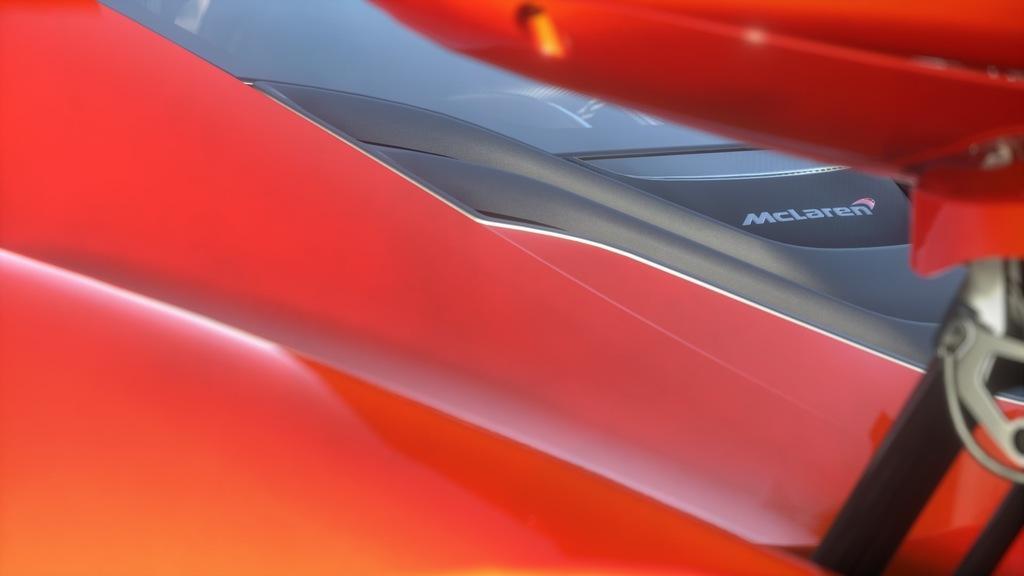Can you describe this image briefly? In this picture we can see a red McLaren car. 